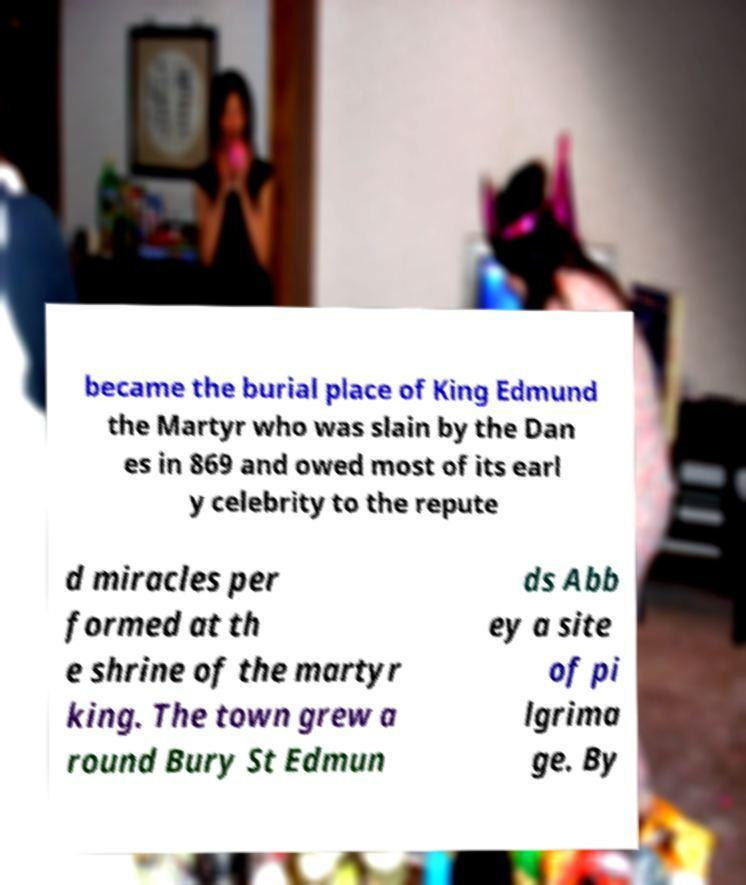I need the written content from this picture converted into text. Can you do that? became the burial place of King Edmund the Martyr who was slain by the Dan es in 869 and owed most of its earl y celebrity to the repute d miracles per formed at th e shrine of the martyr king. The town grew a round Bury St Edmun ds Abb ey a site of pi lgrima ge. By 